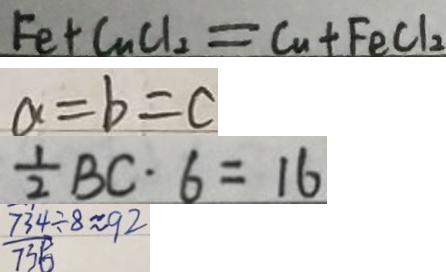<formula> <loc_0><loc_0><loc_500><loc_500>F e + C u C l _ { 2 } = C u + F e C l _ { 2 } 
 a = b = c 
 \frac { 1 } { 2 } B C \cdot 6 = 1 6 
 \frac { 7 3 4 } { 7 3 5 } \div 8 \approx 9 2</formula> 